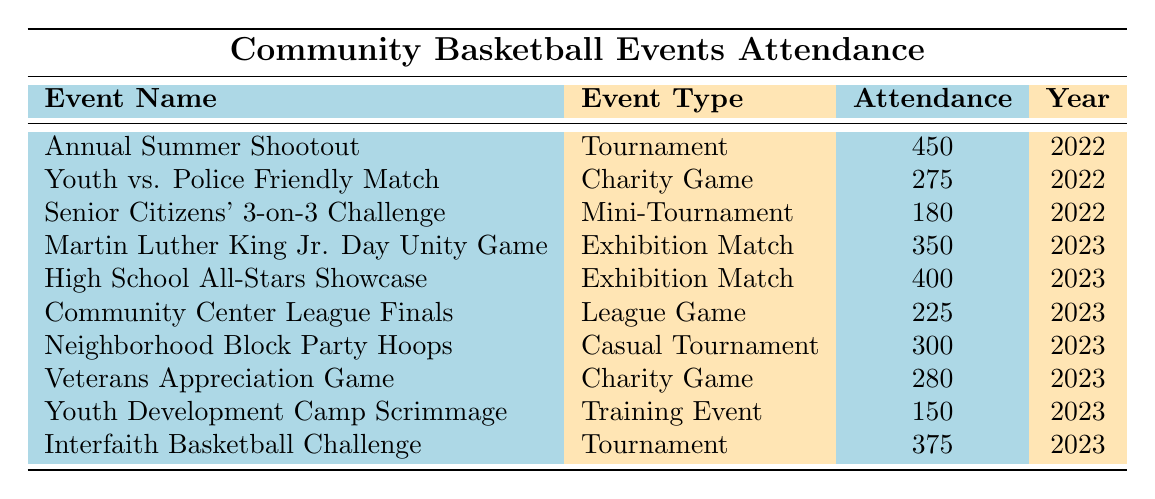What is the attendance for the Annual Summer Shootout? The table lists the Annual Summer Shootout under the "Event Name" column, and the corresponding attendance figure is provided in the "Attendance" column, which shows 450.
Answer: 450 Which event had the highest attendance in 2023? The events of 2023 are: Martin Luther King Jr. Day Unity Game (350), High School All-Stars Showcase (400), Community Center League Finals (225), Neighborhood Block Party Hoops (300), Veterans Appreciation Game (280), Youth Development Camp Scrimmage (150), and Interfaith Basketball Challenge (375). The highest attendance is identified in the High School All-Stars Showcase with 400.
Answer: 400 Is the attendance for the Youth Development Camp Scrimmage greater than 200? The attendance for the Youth Development Camp Scrimmage is recorded as 150 in the table. Since 150 is less than 200, the answer is no.
Answer: No What is the total attendance for all charity games? The charity games listed are: Youth vs. Police Friendly Match (275) and Veterans Appreciation Game (280). Adding these figures together, 275 + 280 equals 555, which is the total attendance for charity games.
Answer: 555 How many events attracted more than 300 attendees in 2022? The events in 2022 are: Annual Summer Shootout (450), Youth vs. Police Friendly Match (275), and Senior Citizens' 3-on-3 Challenge (180). Only the Annual Summer Shootout had attendance above 300, so there is 1 event.
Answer: 1 What is the average attendance of all events held in 2023? The attendance figures for 2023 events are: Martin Luther King Jr. Day Unity Game (350), High School All-Stars Showcase (400), Community Center League Finals (225), Neighborhood Block Party Hoops (300), Veterans Appreciation Game (280), Youth Development Camp Scrimmage (150), and Interfaith Basketball Challenge (375). Summing them gives 350 + 400 + 225 + 300 + 280 + 150 + 375 = 2080. There are 7 events, so the average is 2080/7 = approximately 297.14.
Answer: 297.14 Which type of event had the least attendance overall? Reviewing the attendance figures for each event, the Senior Citizens' 3-on-3 Challenge has the lowest attendance at 180 among the listed events.
Answer: 180 How many years were events held according to the data? The table shows events from two different years: 2022 and 2023. Thus, there are two years spanned by the events.
Answer: 2 What is the difference in attendance between the highest and lowest events in 2023? The highest attendance in 2023 is from the High School All-Stars Showcase with 400 attendees, while the lowest is from the Youth Development Camp Scrimmage with 150 attendees. Calculating the difference: 400 - 150 equals 250.
Answer: 250 Did any mini-tournaments take place in 2023? The only mini-tournament listed in the table is the Senior Citizens' 3-on-3 Challenge, which was held in 2022. Therefore, there were no mini-tournaments in 2023.
Answer: No How many events had an attendance of fewer than 250 participants? The events with attendance below 250 are: Community Center League Finals (225), Youth Development Camp Scrimmage (150), and Senior Citizens' 3-on-3 Challenge (180). That makes a total of 3 events.
Answer: 3 